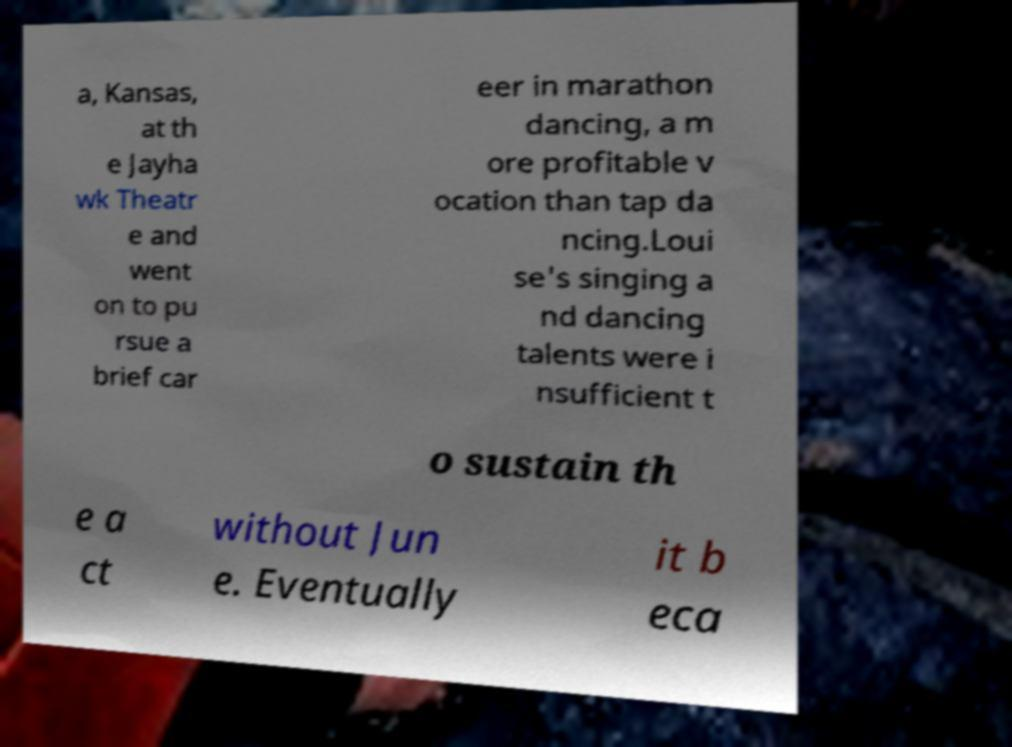Could you assist in decoding the text presented in this image and type it out clearly? a, Kansas, at th e Jayha wk Theatr e and went on to pu rsue a brief car eer in marathon dancing, a m ore profitable v ocation than tap da ncing.Loui se's singing a nd dancing talents were i nsufficient t o sustain th e a ct without Jun e. Eventually it b eca 